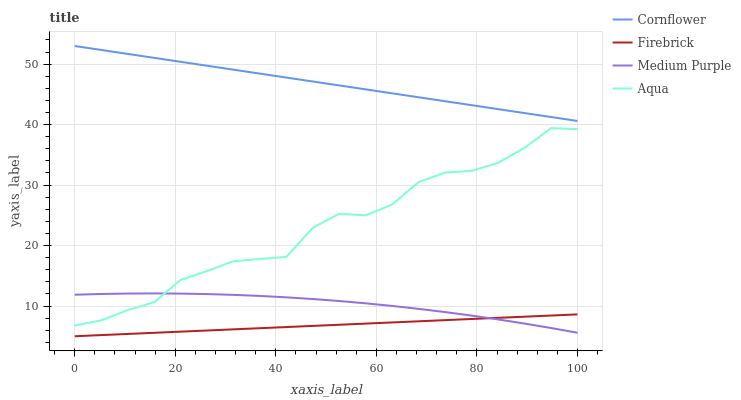Does Firebrick have the minimum area under the curve?
Answer yes or no. Yes. Does Cornflower have the maximum area under the curve?
Answer yes or no. Yes. Does Cornflower have the minimum area under the curve?
Answer yes or no. No. Does Firebrick have the maximum area under the curve?
Answer yes or no. No. Is Firebrick the smoothest?
Answer yes or no. Yes. Is Aqua the roughest?
Answer yes or no. Yes. Is Cornflower the smoothest?
Answer yes or no. No. Is Cornflower the roughest?
Answer yes or no. No. Does Firebrick have the lowest value?
Answer yes or no. Yes. Does Cornflower have the lowest value?
Answer yes or no. No. Does Cornflower have the highest value?
Answer yes or no. Yes. Does Firebrick have the highest value?
Answer yes or no. No. Is Aqua less than Cornflower?
Answer yes or no. Yes. Is Cornflower greater than Medium Purple?
Answer yes or no. Yes. Does Medium Purple intersect Aqua?
Answer yes or no. Yes. Is Medium Purple less than Aqua?
Answer yes or no. No. Is Medium Purple greater than Aqua?
Answer yes or no. No. Does Aqua intersect Cornflower?
Answer yes or no. No. 